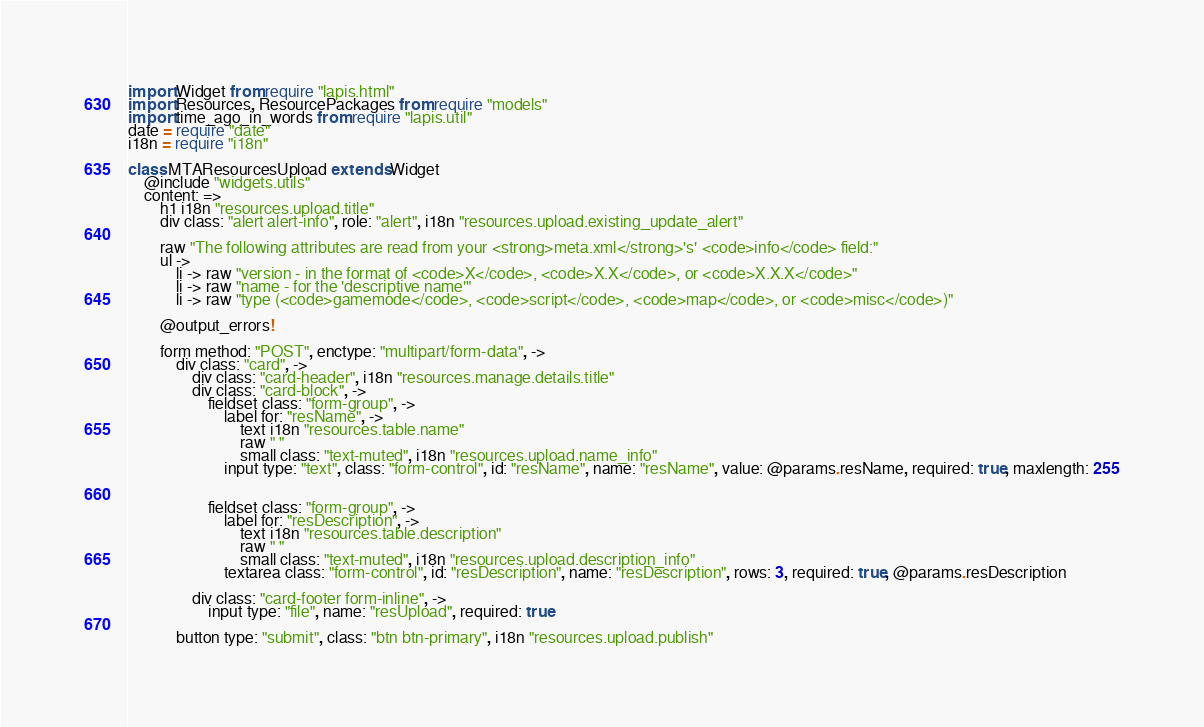Convert code to text. <code><loc_0><loc_0><loc_500><loc_500><_MoonScript_>import Widget from require "lapis.html"
import Resources, ResourcePackages from require "models"
import time_ago_in_words from require "lapis.util"
date = require "date"
i18n = require "i18n"

class MTAResourcesUpload extends Widget
	@include "widgets.utils"
	content: =>
		h1 i18n "resources.upload.title"
		div class: "alert alert-info", role: "alert", i18n "resources.upload.existing_update_alert"

		raw "The following attributes are read from your <strong>meta.xml</strong>'s' <code>info</code> field:"
		ul ->
			li -> raw "version - in the format of <code>X</code>, <code>X.X</code>, or <code>X.X.X</code>"
			li -> raw "name - for the 'descriptive name'" 
			li -> raw "type (<code>gamemode</code>, <code>script</code>, <code>map</code>, or <code>misc</code>)"

		@output_errors!

		form method: "POST", enctype: "multipart/form-data", ->
			div class: "card", ->
				div class: "card-header", i18n "resources.manage.details.title"
				div class: "card-block", ->
					fieldset class: "form-group", ->
						label for: "resName", ->
							text i18n "resources.table.name"
							raw " "
							small class: "text-muted", i18n "resources.upload.name_info"
						input type: "text", class: "form-control", id: "resName", name: "resName", value: @params.resName, required: true, maxlength: 255
						
					
					fieldset class: "form-group", ->
						label for: "resDescription", ->
							text i18n "resources.table.description"
							raw " "
							small class: "text-muted", i18n "resources.upload.description_info"
						textarea class: "form-control", id: "resDescription", name: "resDescription", rows: 3, required: true, @params.resDescription
			
				div class: "card-footer form-inline", ->
					input type: "file", name: "resUpload", required: true
			
			button type: "submit", class: "btn btn-primary", i18n "resources.upload.publish"</code> 